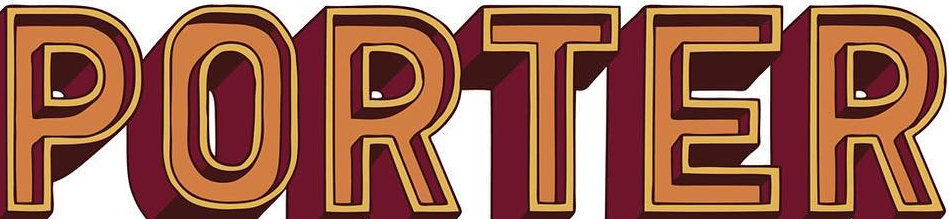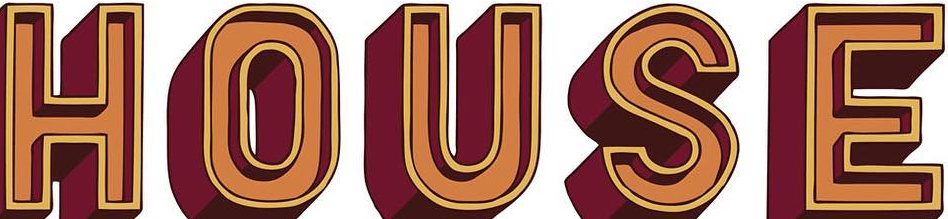Read the text from these images in sequence, separated by a semicolon. PORTER; HOUSE 